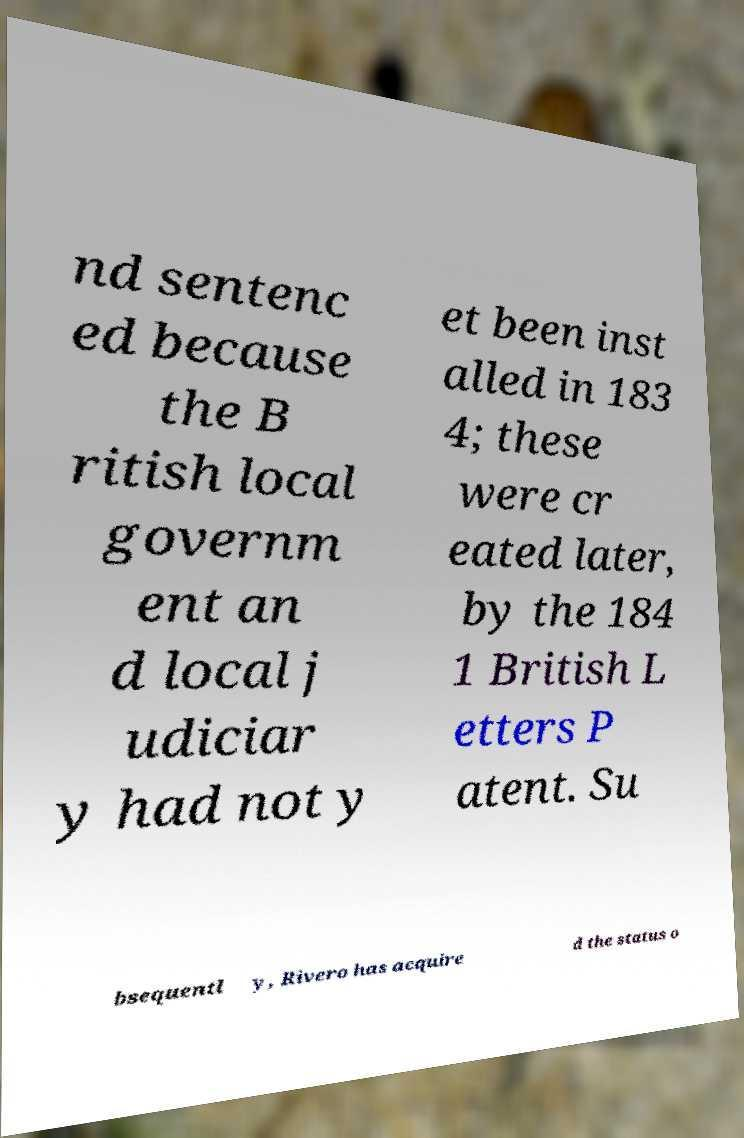There's text embedded in this image that I need extracted. Can you transcribe it verbatim? nd sentenc ed because the B ritish local governm ent an d local j udiciar y had not y et been inst alled in 183 4; these were cr eated later, by the 184 1 British L etters P atent. Su bsequentl y, Rivero has acquire d the status o 